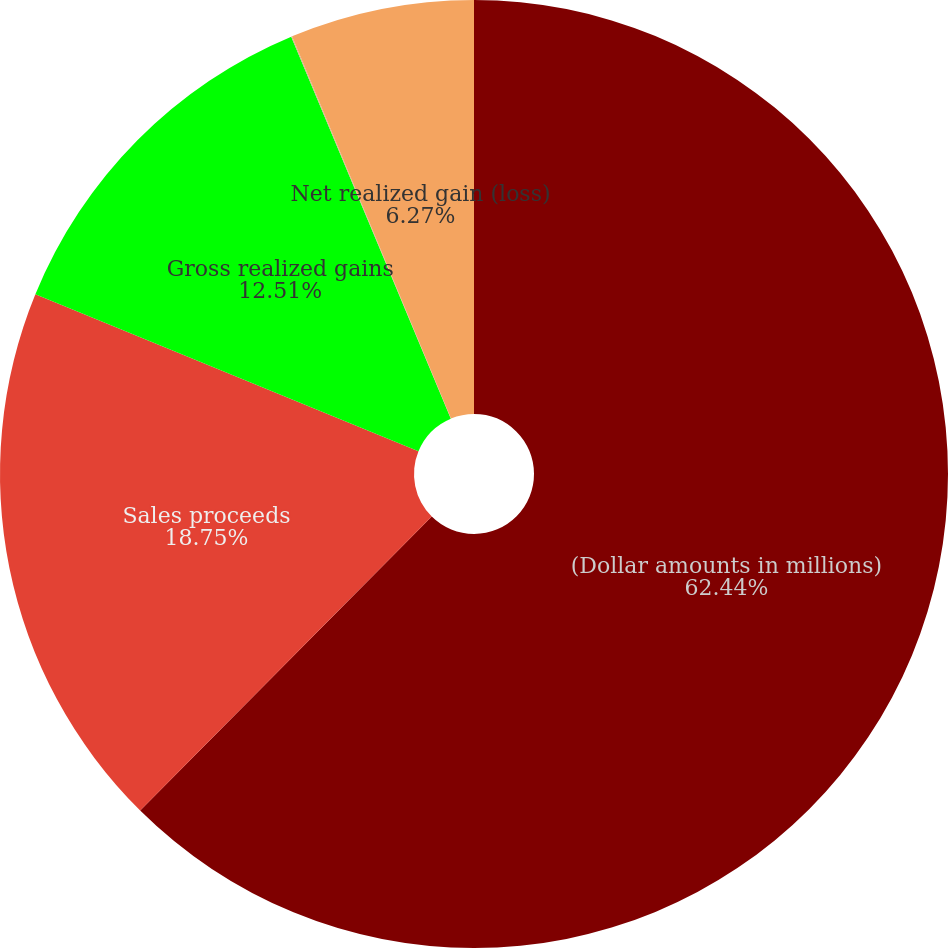<chart> <loc_0><loc_0><loc_500><loc_500><pie_chart><fcel>(Dollar amounts in millions)<fcel>Sales proceeds<fcel>Gross realized gains<fcel>Grossrealizedlosses<fcel>Net realized gain (loss)<nl><fcel>62.43%<fcel>18.75%<fcel>12.51%<fcel>0.03%<fcel>6.27%<nl></chart> 